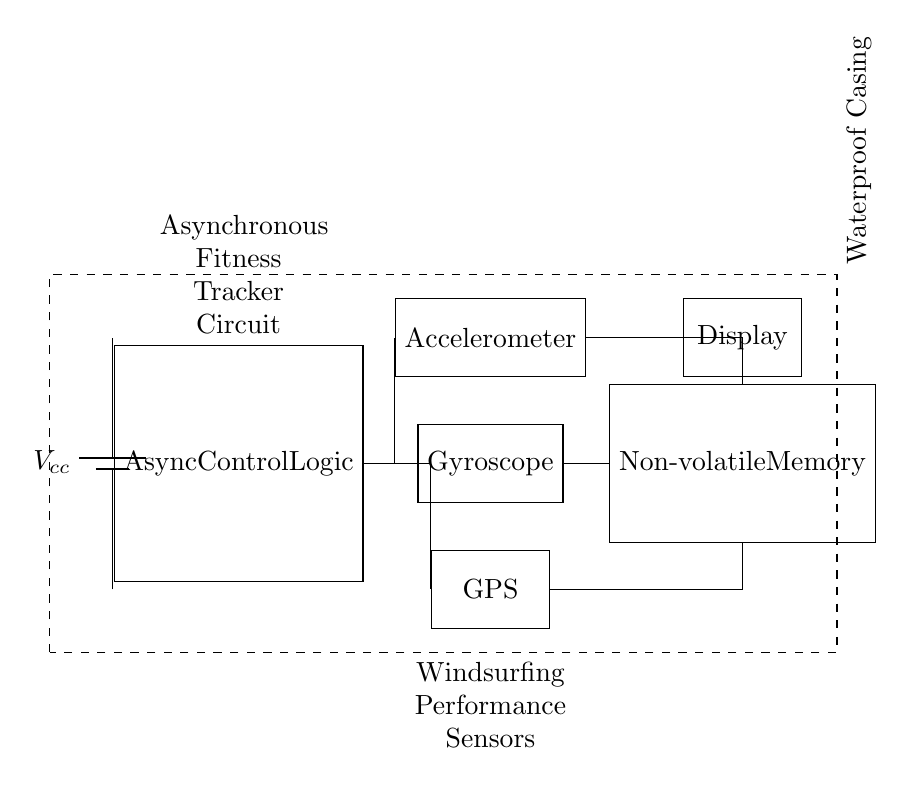What is the power supply voltage in this circuit? The circuit shows a battery labeled Vcc, which represents the power supply voltage. Without specific values indicated, we assume it to be a standard battery voltage used in fitness trackers, typically 3.7 volts.
Answer: 3.7 volts What types of sensors are included in the circuit? The circuit diagram includes three sensors: an accelerometer, a gyroscope, and a GPS. These components are labeled and positioned clearly in the diagram.
Answer: Accelerometer, gyroscope, GPS Where does the control logic connect in the circuit? The control logic connects to all three sensors: the accelerometer, gyroscope, and GPS. The connections are shown using lines leading from the control block to each sensor.
Answer: To the accelerometer, gyroscope, and GPS What type of memory is utilized in this tracker? The memory is described as non-volatile memory in the circuit, which retains stored data even when the power is off. This is essential for keeping performance data.
Answer: Non-volatile memory How does data flow from the sensors to the display? Data flows from the sensors to the control logic, then to non-volatile memory, and finally from memory to the display. This flow is indicated by the connections in the diagram, outlining the sequence of operations.
Answer: From sensors to control logic, to memory, then to display What is the purpose of the waterproof casing in the circuit? The waterproof casing is essential for protecting the internal components such as the sensors and control logic from water damage, allowing the tracker to be used in wet conditions while windsurfing.
Answer: To protect internal components from water What type of circuit is this? The circuit is categorized as an asynchronous circuit, indicating that the components operate without a clock signal coordinating their actions. This type of circuit is indicated in the label of the control logic.
Answer: Asynchronous circuit 